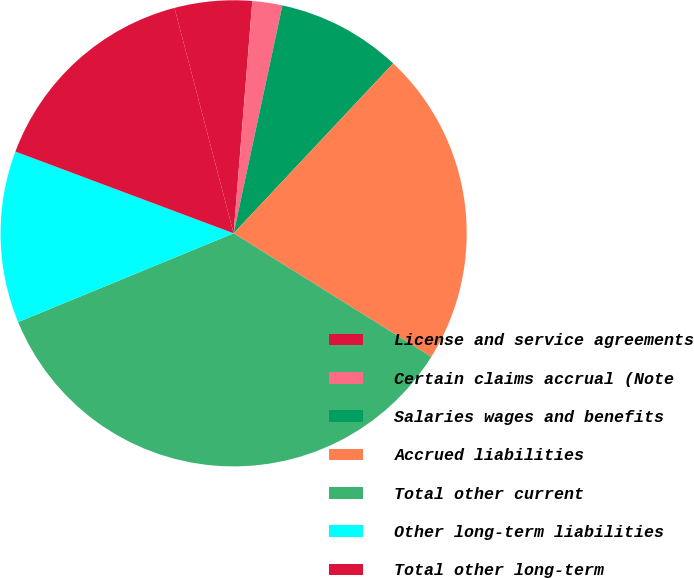Convert chart to OTSL. <chart><loc_0><loc_0><loc_500><loc_500><pie_chart><fcel>License and service agreements<fcel>Certain claims accrual (Note<fcel>Salaries wages and benefits<fcel>Accrued liabilities<fcel>Total other current<fcel>Other long-term liabilities<fcel>Total other long-term<nl><fcel>5.36%<fcel>2.08%<fcel>8.64%<fcel>21.89%<fcel>34.89%<fcel>11.92%<fcel>15.21%<nl></chart> 